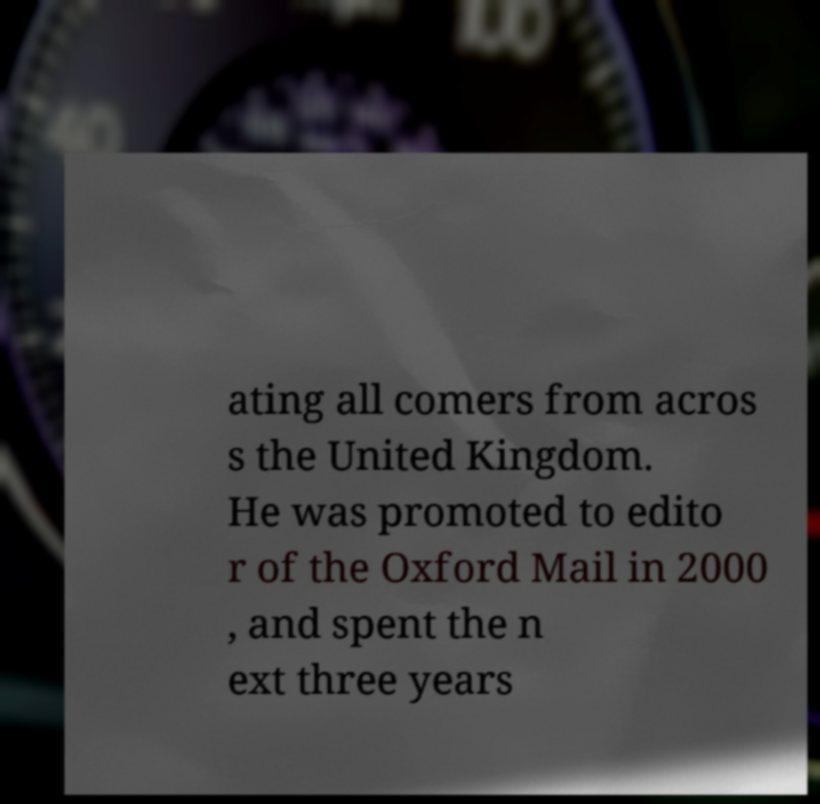Can you accurately transcribe the text from the provided image for me? ating all comers from acros s the United Kingdom. He was promoted to edito r of the Oxford Mail in 2000 , and spent the n ext three years 